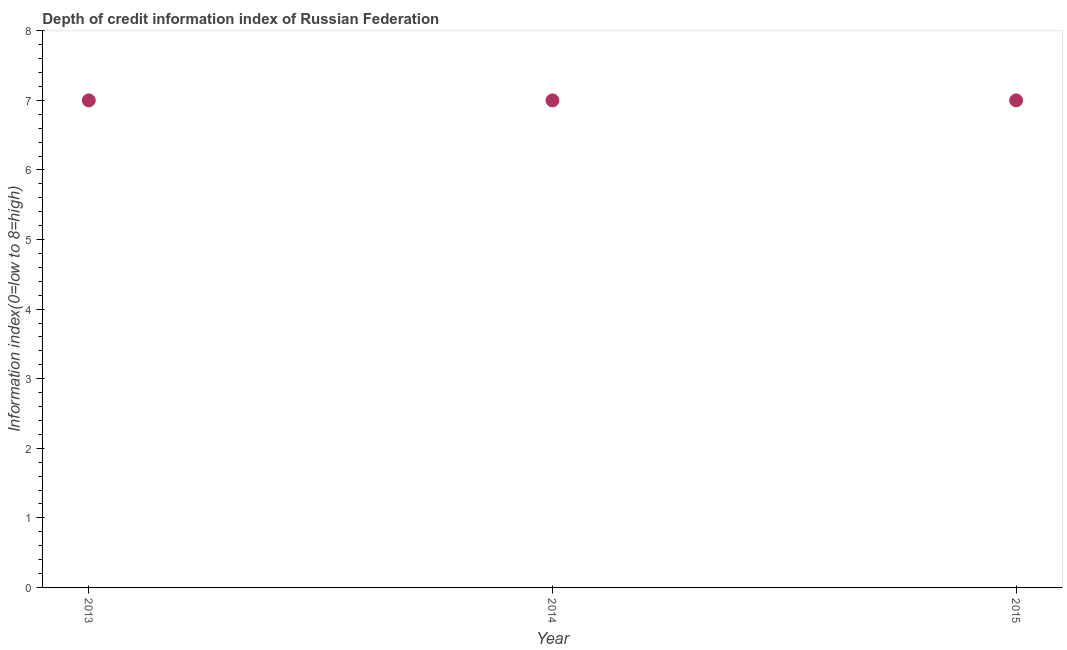What is the depth of credit information index in 2015?
Ensure brevity in your answer.  7. Across all years, what is the maximum depth of credit information index?
Your answer should be compact. 7. Across all years, what is the minimum depth of credit information index?
Give a very brief answer. 7. In which year was the depth of credit information index maximum?
Keep it short and to the point. 2013. In which year was the depth of credit information index minimum?
Ensure brevity in your answer.  2013. What is the sum of the depth of credit information index?
Ensure brevity in your answer.  21. What is the difference between the depth of credit information index in 2014 and 2015?
Offer a very short reply. 0. What is the average depth of credit information index per year?
Offer a terse response. 7. What is the median depth of credit information index?
Your answer should be very brief. 7. In how many years, is the depth of credit information index greater than 0.2 ?
Keep it short and to the point. 3. Is the depth of credit information index in 2013 less than that in 2014?
Your answer should be very brief. No. Is the difference between the depth of credit information index in 2014 and 2015 greater than the difference between any two years?
Offer a terse response. Yes. Is the sum of the depth of credit information index in 2013 and 2015 greater than the maximum depth of credit information index across all years?
Make the answer very short. Yes. In how many years, is the depth of credit information index greater than the average depth of credit information index taken over all years?
Provide a succinct answer. 0. Does the depth of credit information index monotonically increase over the years?
Provide a succinct answer. No. How many dotlines are there?
Provide a short and direct response. 1. What is the difference between two consecutive major ticks on the Y-axis?
Offer a terse response. 1. What is the title of the graph?
Ensure brevity in your answer.  Depth of credit information index of Russian Federation. What is the label or title of the Y-axis?
Your response must be concise. Information index(0=low to 8=high). What is the Information index(0=low to 8=high) in 2013?
Keep it short and to the point. 7. What is the Information index(0=low to 8=high) in 2014?
Your response must be concise. 7. What is the difference between the Information index(0=low to 8=high) in 2013 and 2014?
Your answer should be very brief. 0. 